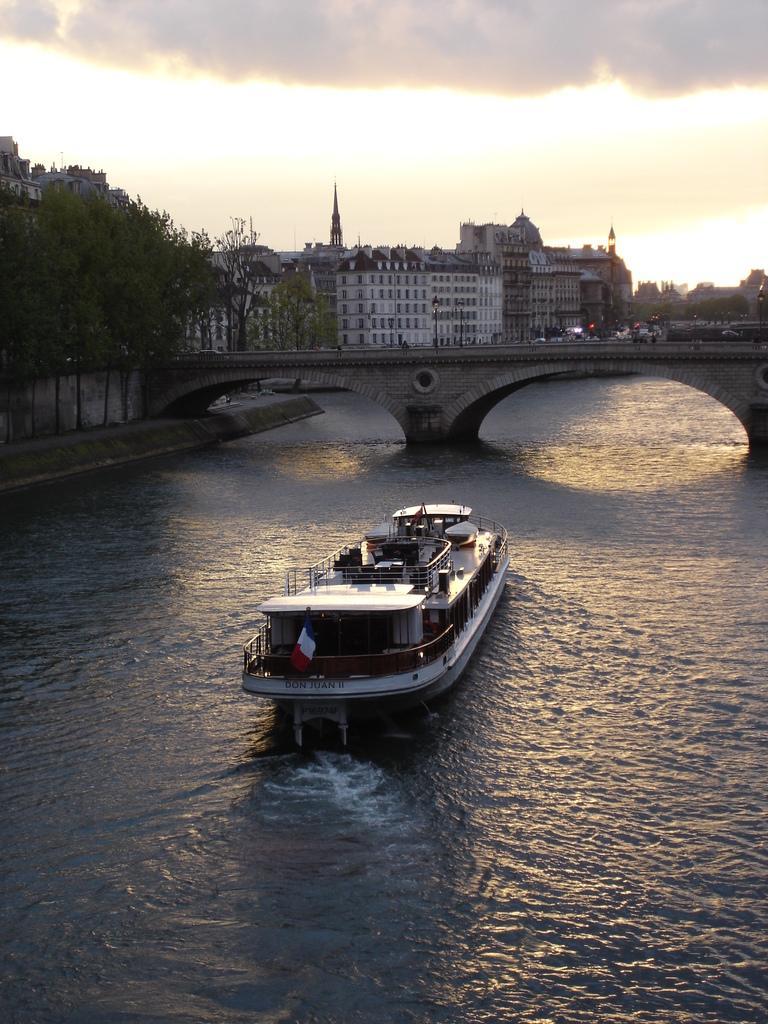How would you summarize this image in a sentence or two? In the center of the image we can see ship on the water. In the background we can see bridge, trees, buildings, lights, sky and clouds. 